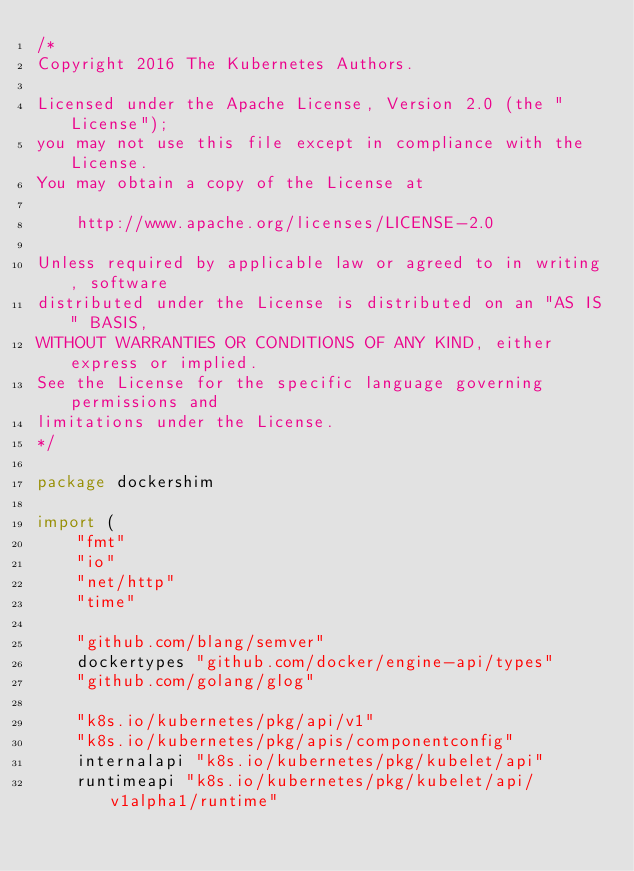<code> <loc_0><loc_0><loc_500><loc_500><_Go_>/*
Copyright 2016 The Kubernetes Authors.

Licensed under the Apache License, Version 2.0 (the "License");
you may not use this file except in compliance with the License.
You may obtain a copy of the License at

    http://www.apache.org/licenses/LICENSE-2.0

Unless required by applicable law or agreed to in writing, software
distributed under the License is distributed on an "AS IS" BASIS,
WITHOUT WARRANTIES OR CONDITIONS OF ANY KIND, either express or implied.
See the License for the specific language governing permissions and
limitations under the License.
*/

package dockershim

import (
	"fmt"
	"io"
	"net/http"
	"time"

	"github.com/blang/semver"
	dockertypes "github.com/docker/engine-api/types"
	"github.com/golang/glog"

	"k8s.io/kubernetes/pkg/api/v1"
	"k8s.io/kubernetes/pkg/apis/componentconfig"
	internalapi "k8s.io/kubernetes/pkg/kubelet/api"
	runtimeapi "k8s.io/kubernetes/pkg/kubelet/api/v1alpha1/runtime"</code> 